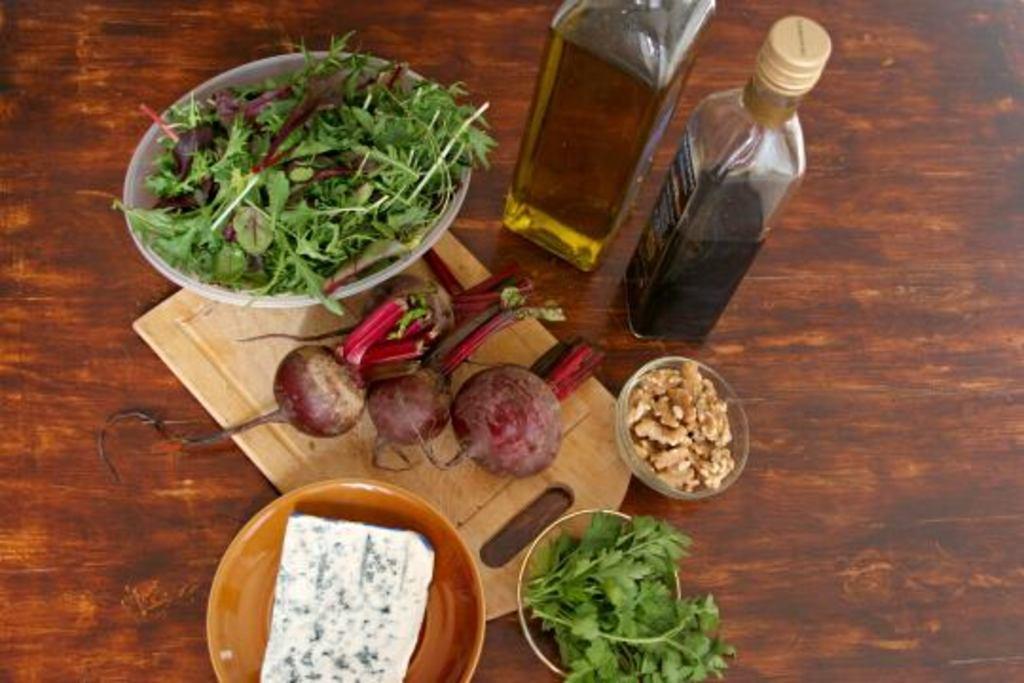Could you give a brief overview of what you see in this image? In this image there are some vegetables it could be oil bottles are there on the table table is chocolate in color. 